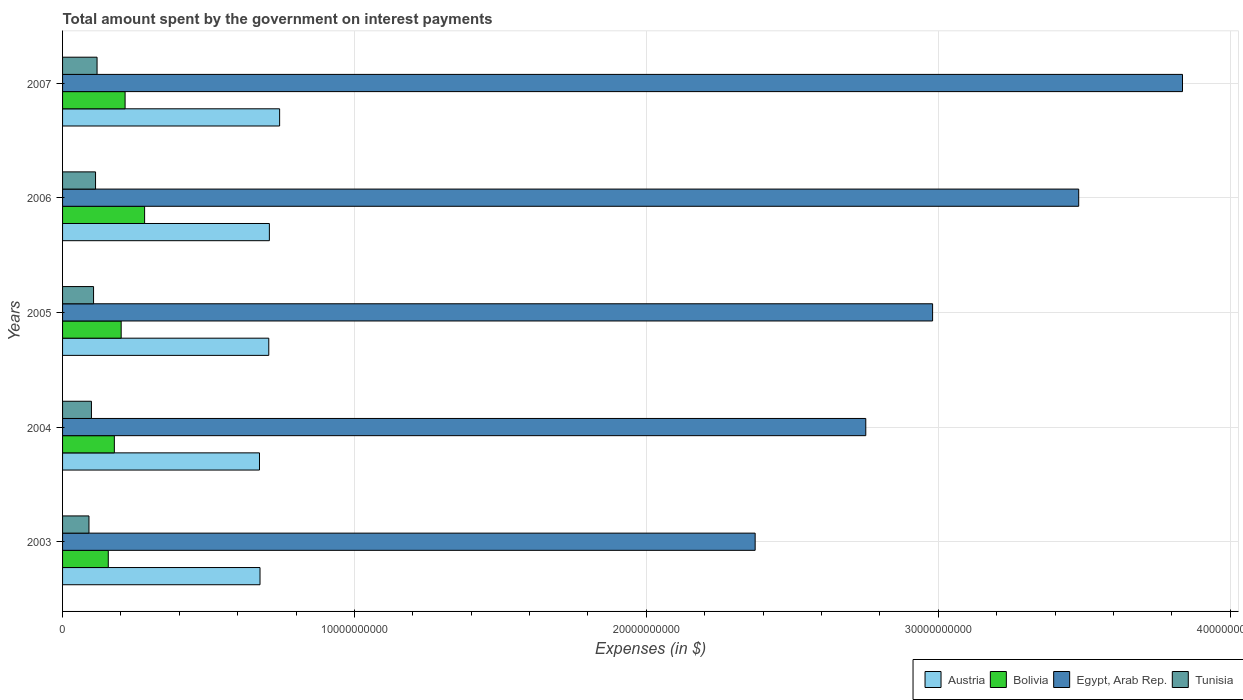Are the number of bars on each tick of the Y-axis equal?
Your answer should be compact. Yes. How many bars are there on the 1st tick from the top?
Keep it short and to the point. 4. What is the label of the 2nd group of bars from the top?
Your response must be concise. 2006. In how many cases, is the number of bars for a given year not equal to the number of legend labels?
Your answer should be compact. 0. What is the amount spent on interest payments by the government in Tunisia in 2006?
Ensure brevity in your answer.  1.13e+09. Across all years, what is the maximum amount spent on interest payments by the government in Bolivia?
Make the answer very short. 2.81e+09. Across all years, what is the minimum amount spent on interest payments by the government in Austria?
Give a very brief answer. 6.75e+09. In which year was the amount spent on interest payments by the government in Austria maximum?
Your answer should be compact. 2007. What is the total amount spent on interest payments by the government in Tunisia in the graph?
Your answer should be very brief. 5.27e+09. What is the difference between the amount spent on interest payments by the government in Bolivia in 2003 and that in 2005?
Keep it short and to the point. -4.42e+08. What is the difference between the amount spent on interest payments by the government in Bolivia in 2006 and the amount spent on interest payments by the government in Egypt, Arab Rep. in 2005?
Your response must be concise. -2.70e+1. What is the average amount spent on interest payments by the government in Bolivia per year?
Your answer should be compact. 2.06e+09. In the year 2007, what is the difference between the amount spent on interest payments by the government in Austria and amount spent on interest payments by the government in Egypt, Arab Rep.?
Provide a short and direct response. -3.09e+1. What is the ratio of the amount spent on interest payments by the government in Tunisia in 2003 to that in 2005?
Your answer should be compact. 0.85. Is the amount spent on interest payments by the government in Bolivia in 2003 less than that in 2006?
Offer a terse response. Yes. What is the difference between the highest and the second highest amount spent on interest payments by the government in Tunisia?
Ensure brevity in your answer.  5.21e+07. What is the difference between the highest and the lowest amount spent on interest payments by the government in Tunisia?
Keep it short and to the point. 2.78e+08. Is it the case that in every year, the sum of the amount spent on interest payments by the government in Bolivia and amount spent on interest payments by the government in Egypt, Arab Rep. is greater than the sum of amount spent on interest payments by the government in Tunisia and amount spent on interest payments by the government in Austria?
Provide a succinct answer. No. What does the 4th bar from the top in 2006 represents?
Your answer should be very brief. Austria. Are all the bars in the graph horizontal?
Your response must be concise. Yes. How many years are there in the graph?
Offer a terse response. 5. What is the difference between two consecutive major ticks on the X-axis?
Make the answer very short. 1.00e+1. Does the graph contain any zero values?
Offer a terse response. No. How are the legend labels stacked?
Your response must be concise. Horizontal. What is the title of the graph?
Keep it short and to the point. Total amount spent by the government on interest payments. What is the label or title of the X-axis?
Make the answer very short. Expenses (in $). What is the label or title of the Y-axis?
Make the answer very short. Years. What is the Expenses (in $) in Austria in 2003?
Your response must be concise. 6.76e+09. What is the Expenses (in $) in Bolivia in 2003?
Offer a terse response. 1.57e+09. What is the Expenses (in $) in Egypt, Arab Rep. in 2003?
Ensure brevity in your answer.  2.37e+1. What is the Expenses (in $) of Tunisia in 2003?
Offer a very short reply. 9.04e+08. What is the Expenses (in $) of Austria in 2004?
Ensure brevity in your answer.  6.75e+09. What is the Expenses (in $) in Bolivia in 2004?
Your response must be concise. 1.77e+09. What is the Expenses (in $) in Egypt, Arab Rep. in 2004?
Make the answer very short. 2.75e+1. What is the Expenses (in $) in Tunisia in 2004?
Offer a very short reply. 9.89e+08. What is the Expenses (in $) of Austria in 2005?
Provide a short and direct response. 7.06e+09. What is the Expenses (in $) of Bolivia in 2005?
Keep it short and to the point. 2.01e+09. What is the Expenses (in $) in Egypt, Arab Rep. in 2005?
Give a very brief answer. 2.98e+1. What is the Expenses (in $) of Tunisia in 2005?
Your response must be concise. 1.06e+09. What is the Expenses (in $) in Austria in 2006?
Your answer should be compact. 7.09e+09. What is the Expenses (in $) in Bolivia in 2006?
Your answer should be compact. 2.81e+09. What is the Expenses (in $) in Egypt, Arab Rep. in 2006?
Provide a succinct answer. 3.48e+1. What is the Expenses (in $) in Tunisia in 2006?
Provide a succinct answer. 1.13e+09. What is the Expenses (in $) in Austria in 2007?
Your response must be concise. 7.44e+09. What is the Expenses (in $) in Bolivia in 2007?
Offer a very short reply. 2.14e+09. What is the Expenses (in $) in Egypt, Arab Rep. in 2007?
Make the answer very short. 3.84e+1. What is the Expenses (in $) of Tunisia in 2007?
Provide a succinct answer. 1.18e+09. Across all years, what is the maximum Expenses (in $) of Austria?
Provide a short and direct response. 7.44e+09. Across all years, what is the maximum Expenses (in $) of Bolivia?
Make the answer very short. 2.81e+09. Across all years, what is the maximum Expenses (in $) in Egypt, Arab Rep.?
Offer a very short reply. 3.84e+1. Across all years, what is the maximum Expenses (in $) of Tunisia?
Offer a very short reply. 1.18e+09. Across all years, what is the minimum Expenses (in $) of Austria?
Provide a succinct answer. 6.75e+09. Across all years, what is the minimum Expenses (in $) of Bolivia?
Provide a succinct answer. 1.57e+09. Across all years, what is the minimum Expenses (in $) in Egypt, Arab Rep.?
Provide a short and direct response. 2.37e+1. Across all years, what is the minimum Expenses (in $) of Tunisia?
Offer a very short reply. 9.04e+08. What is the total Expenses (in $) in Austria in the graph?
Your response must be concise. 3.51e+1. What is the total Expenses (in $) of Bolivia in the graph?
Give a very brief answer. 1.03e+1. What is the total Expenses (in $) in Egypt, Arab Rep. in the graph?
Your answer should be compact. 1.54e+11. What is the total Expenses (in $) of Tunisia in the graph?
Your answer should be compact. 5.27e+09. What is the difference between the Expenses (in $) in Austria in 2003 and that in 2004?
Ensure brevity in your answer.  1.82e+07. What is the difference between the Expenses (in $) in Bolivia in 2003 and that in 2004?
Your response must be concise. -2.08e+08. What is the difference between the Expenses (in $) of Egypt, Arab Rep. in 2003 and that in 2004?
Offer a very short reply. -3.79e+09. What is the difference between the Expenses (in $) of Tunisia in 2003 and that in 2004?
Provide a short and direct response. -8.47e+07. What is the difference between the Expenses (in $) in Austria in 2003 and that in 2005?
Ensure brevity in your answer.  -3.00e+08. What is the difference between the Expenses (in $) of Bolivia in 2003 and that in 2005?
Your answer should be very brief. -4.42e+08. What is the difference between the Expenses (in $) of Egypt, Arab Rep. in 2003 and that in 2005?
Keep it short and to the point. -6.08e+09. What is the difference between the Expenses (in $) of Tunisia in 2003 and that in 2005?
Keep it short and to the point. -1.58e+08. What is the difference between the Expenses (in $) of Austria in 2003 and that in 2006?
Make the answer very short. -3.20e+08. What is the difference between the Expenses (in $) of Bolivia in 2003 and that in 2006?
Your answer should be compact. -1.24e+09. What is the difference between the Expenses (in $) in Egypt, Arab Rep. in 2003 and that in 2006?
Offer a terse response. -1.11e+1. What is the difference between the Expenses (in $) of Tunisia in 2003 and that in 2006?
Provide a short and direct response. -2.26e+08. What is the difference between the Expenses (in $) of Austria in 2003 and that in 2007?
Provide a succinct answer. -6.72e+08. What is the difference between the Expenses (in $) of Bolivia in 2003 and that in 2007?
Keep it short and to the point. -5.76e+08. What is the difference between the Expenses (in $) of Egypt, Arab Rep. in 2003 and that in 2007?
Provide a short and direct response. -1.46e+1. What is the difference between the Expenses (in $) of Tunisia in 2003 and that in 2007?
Your answer should be very brief. -2.78e+08. What is the difference between the Expenses (in $) in Austria in 2004 and that in 2005?
Offer a very short reply. -3.18e+08. What is the difference between the Expenses (in $) in Bolivia in 2004 and that in 2005?
Make the answer very short. -2.34e+08. What is the difference between the Expenses (in $) in Egypt, Arab Rep. in 2004 and that in 2005?
Your response must be concise. -2.29e+09. What is the difference between the Expenses (in $) in Tunisia in 2004 and that in 2005?
Make the answer very short. -7.31e+07. What is the difference between the Expenses (in $) of Austria in 2004 and that in 2006?
Offer a very short reply. -3.39e+08. What is the difference between the Expenses (in $) of Bolivia in 2004 and that in 2006?
Offer a terse response. -1.04e+09. What is the difference between the Expenses (in $) in Egypt, Arab Rep. in 2004 and that in 2006?
Offer a very short reply. -7.29e+09. What is the difference between the Expenses (in $) of Tunisia in 2004 and that in 2006?
Your answer should be very brief. -1.41e+08. What is the difference between the Expenses (in $) in Austria in 2004 and that in 2007?
Provide a short and direct response. -6.90e+08. What is the difference between the Expenses (in $) in Bolivia in 2004 and that in 2007?
Your answer should be compact. -3.68e+08. What is the difference between the Expenses (in $) of Egypt, Arab Rep. in 2004 and that in 2007?
Provide a succinct answer. -1.09e+1. What is the difference between the Expenses (in $) in Tunisia in 2004 and that in 2007?
Your answer should be very brief. -1.93e+08. What is the difference between the Expenses (in $) in Austria in 2005 and that in 2006?
Ensure brevity in your answer.  -2.02e+07. What is the difference between the Expenses (in $) in Bolivia in 2005 and that in 2006?
Give a very brief answer. -8.03e+08. What is the difference between the Expenses (in $) of Egypt, Arab Rep. in 2005 and that in 2006?
Your answer should be compact. -5.01e+09. What is the difference between the Expenses (in $) of Tunisia in 2005 and that in 2006?
Offer a very short reply. -6.77e+07. What is the difference between the Expenses (in $) in Austria in 2005 and that in 2007?
Offer a terse response. -3.71e+08. What is the difference between the Expenses (in $) of Bolivia in 2005 and that in 2007?
Give a very brief answer. -1.34e+08. What is the difference between the Expenses (in $) of Egypt, Arab Rep. in 2005 and that in 2007?
Ensure brevity in your answer.  -8.56e+09. What is the difference between the Expenses (in $) in Tunisia in 2005 and that in 2007?
Keep it short and to the point. -1.20e+08. What is the difference between the Expenses (in $) of Austria in 2006 and that in 2007?
Offer a terse response. -3.51e+08. What is the difference between the Expenses (in $) in Bolivia in 2006 and that in 2007?
Provide a succinct answer. 6.69e+08. What is the difference between the Expenses (in $) of Egypt, Arab Rep. in 2006 and that in 2007?
Keep it short and to the point. -3.56e+09. What is the difference between the Expenses (in $) of Tunisia in 2006 and that in 2007?
Offer a terse response. -5.21e+07. What is the difference between the Expenses (in $) of Austria in 2003 and the Expenses (in $) of Bolivia in 2004?
Provide a succinct answer. 4.99e+09. What is the difference between the Expenses (in $) in Austria in 2003 and the Expenses (in $) in Egypt, Arab Rep. in 2004?
Your answer should be very brief. -2.08e+1. What is the difference between the Expenses (in $) of Austria in 2003 and the Expenses (in $) of Tunisia in 2004?
Give a very brief answer. 5.78e+09. What is the difference between the Expenses (in $) of Bolivia in 2003 and the Expenses (in $) of Egypt, Arab Rep. in 2004?
Provide a succinct answer. -2.60e+1. What is the difference between the Expenses (in $) in Bolivia in 2003 and the Expenses (in $) in Tunisia in 2004?
Your answer should be compact. 5.77e+08. What is the difference between the Expenses (in $) in Egypt, Arab Rep. in 2003 and the Expenses (in $) in Tunisia in 2004?
Give a very brief answer. 2.27e+1. What is the difference between the Expenses (in $) of Austria in 2003 and the Expenses (in $) of Bolivia in 2005?
Make the answer very short. 4.76e+09. What is the difference between the Expenses (in $) in Austria in 2003 and the Expenses (in $) in Egypt, Arab Rep. in 2005?
Keep it short and to the point. -2.30e+1. What is the difference between the Expenses (in $) of Austria in 2003 and the Expenses (in $) of Tunisia in 2005?
Keep it short and to the point. 5.70e+09. What is the difference between the Expenses (in $) of Bolivia in 2003 and the Expenses (in $) of Egypt, Arab Rep. in 2005?
Provide a short and direct response. -2.82e+1. What is the difference between the Expenses (in $) of Bolivia in 2003 and the Expenses (in $) of Tunisia in 2005?
Your response must be concise. 5.04e+08. What is the difference between the Expenses (in $) in Egypt, Arab Rep. in 2003 and the Expenses (in $) in Tunisia in 2005?
Offer a very short reply. 2.27e+1. What is the difference between the Expenses (in $) of Austria in 2003 and the Expenses (in $) of Bolivia in 2006?
Provide a succinct answer. 3.95e+09. What is the difference between the Expenses (in $) of Austria in 2003 and the Expenses (in $) of Egypt, Arab Rep. in 2006?
Keep it short and to the point. -2.80e+1. What is the difference between the Expenses (in $) in Austria in 2003 and the Expenses (in $) in Tunisia in 2006?
Your answer should be very brief. 5.63e+09. What is the difference between the Expenses (in $) in Bolivia in 2003 and the Expenses (in $) in Egypt, Arab Rep. in 2006?
Provide a succinct answer. -3.32e+1. What is the difference between the Expenses (in $) in Bolivia in 2003 and the Expenses (in $) in Tunisia in 2006?
Keep it short and to the point. 4.36e+08. What is the difference between the Expenses (in $) of Egypt, Arab Rep. in 2003 and the Expenses (in $) of Tunisia in 2006?
Offer a terse response. 2.26e+1. What is the difference between the Expenses (in $) of Austria in 2003 and the Expenses (in $) of Bolivia in 2007?
Ensure brevity in your answer.  4.62e+09. What is the difference between the Expenses (in $) of Austria in 2003 and the Expenses (in $) of Egypt, Arab Rep. in 2007?
Your response must be concise. -3.16e+1. What is the difference between the Expenses (in $) in Austria in 2003 and the Expenses (in $) in Tunisia in 2007?
Ensure brevity in your answer.  5.58e+09. What is the difference between the Expenses (in $) of Bolivia in 2003 and the Expenses (in $) of Egypt, Arab Rep. in 2007?
Keep it short and to the point. -3.68e+1. What is the difference between the Expenses (in $) in Bolivia in 2003 and the Expenses (in $) in Tunisia in 2007?
Provide a succinct answer. 3.84e+08. What is the difference between the Expenses (in $) of Egypt, Arab Rep. in 2003 and the Expenses (in $) of Tunisia in 2007?
Offer a very short reply. 2.25e+1. What is the difference between the Expenses (in $) in Austria in 2004 and the Expenses (in $) in Bolivia in 2005?
Make the answer very short. 4.74e+09. What is the difference between the Expenses (in $) of Austria in 2004 and the Expenses (in $) of Egypt, Arab Rep. in 2005?
Your answer should be very brief. -2.31e+1. What is the difference between the Expenses (in $) in Austria in 2004 and the Expenses (in $) in Tunisia in 2005?
Offer a terse response. 5.68e+09. What is the difference between the Expenses (in $) of Bolivia in 2004 and the Expenses (in $) of Egypt, Arab Rep. in 2005?
Make the answer very short. -2.80e+1. What is the difference between the Expenses (in $) in Bolivia in 2004 and the Expenses (in $) in Tunisia in 2005?
Offer a very short reply. 7.12e+08. What is the difference between the Expenses (in $) in Egypt, Arab Rep. in 2004 and the Expenses (in $) in Tunisia in 2005?
Ensure brevity in your answer.  2.65e+1. What is the difference between the Expenses (in $) of Austria in 2004 and the Expenses (in $) of Bolivia in 2006?
Ensure brevity in your answer.  3.94e+09. What is the difference between the Expenses (in $) in Austria in 2004 and the Expenses (in $) in Egypt, Arab Rep. in 2006?
Your answer should be compact. -2.81e+1. What is the difference between the Expenses (in $) in Austria in 2004 and the Expenses (in $) in Tunisia in 2006?
Ensure brevity in your answer.  5.62e+09. What is the difference between the Expenses (in $) of Bolivia in 2004 and the Expenses (in $) of Egypt, Arab Rep. in 2006?
Keep it short and to the point. -3.30e+1. What is the difference between the Expenses (in $) in Bolivia in 2004 and the Expenses (in $) in Tunisia in 2006?
Offer a very short reply. 6.44e+08. What is the difference between the Expenses (in $) of Egypt, Arab Rep. in 2004 and the Expenses (in $) of Tunisia in 2006?
Provide a short and direct response. 2.64e+1. What is the difference between the Expenses (in $) of Austria in 2004 and the Expenses (in $) of Bolivia in 2007?
Give a very brief answer. 4.60e+09. What is the difference between the Expenses (in $) in Austria in 2004 and the Expenses (in $) in Egypt, Arab Rep. in 2007?
Give a very brief answer. -3.16e+1. What is the difference between the Expenses (in $) of Austria in 2004 and the Expenses (in $) of Tunisia in 2007?
Your answer should be compact. 5.56e+09. What is the difference between the Expenses (in $) of Bolivia in 2004 and the Expenses (in $) of Egypt, Arab Rep. in 2007?
Give a very brief answer. -3.66e+1. What is the difference between the Expenses (in $) of Bolivia in 2004 and the Expenses (in $) of Tunisia in 2007?
Give a very brief answer. 5.92e+08. What is the difference between the Expenses (in $) of Egypt, Arab Rep. in 2004 and the Expenses (in $) of Tunisia in 2007?
Keep it short and to the point. 2.63e+1. What is the difference between the Expenses (in $) of Austria in 2005 and the Expenses (in $) of Bolivia in 2006?
Provide a succinct answer. 4.25e+09. What is the difference between the Expenses (in $) of Austria in 2005 and the Expenses (in $) of Egypt, Arab Rep. in 2006?
Make the answer very short. -2.77e+1. What is the difference between the Expenses (in $) in Austria in 2005 and the Expenses (in $) in Tunisia in 2006?
Offer a very short reply. 5.94e+09. What is the difference between the Expenses (in $) of Bolivia in 2005 and the Expenses (in $) of Egypt, Arab Rep. in 2006?
Make the answer very short. -3.28e+1. What is the difference between the Expenses (in $) in Bolivia in 2005 and the Expenses (in $) in Tunisia in 2006?
Keep it short and to the point. 8.78e+08. What is the difference between the Expenses (in $) of Egypt, Arab Rep. in 2005 and the Expenses (in $) of Tunisia in 2006?
Provide a succinct answer. 2.87e+1. What is the difference between the Expenses (in $) of Austria in 2005 and the Expenses (in $) of Bolivia in 2007?
Keep it short and to the point. 4.92e+09. What is the difference between the Expenses (in $) of Austria in 2005 and the Expenses (in $) of Egypt, Arab Rep. in 2007?
Keep it short and to the point. -3.13e+1. What is the difference between the Expenses (in $) in Austria in 2005 and the Expenses (in $) in Tunisia in 2007?
Provide a short and direct response. 5.88e+09. What is the difference between the Expenses (in $) of Bolivia in 2005 and the Expenses (in $) of Egypt, Arab Rep. in 2007?
Your answer should be very brief. -3.64e+1. What is the difference between the Expenses (in $) of Bolivia in 2005 and the Expenses (in $) of Tunisia in 2007?
Offer a terse response. 8.26e+08. What is the difference between the Expenses (in $) of Egypt, Arab Rep. in 2005 and the Expenses (in $) of Tunisia in 2007?
Your answer should be compact. 2.86e+1. What is the difference between the Expenses (in $) in Austria in 2006 and the Expenses (in $) in Bolivia in 2007?
Your answer should be very brief. 4.94e+09. What is the difference between the Expenses (in $) of Austria in 2006 and the Expenses (in $) of Egypt, Arab Rep. in 2007?
Offer a terse response. -3.13e+1. What is the difference between the Expenses (in $) in Austria in 2006 and the Expenses (in $) in Tunisia in 2007?
Give a very brief answer. 5.90e+09. What is the difference between the Expenses (in $) of Bolivia in 2006 and the Expenses (in $) of Egypt, Arab Rep. in 2007?
Ensure brevity in your answer.  -3.56e+1. What is the difference between the Expenses (in $) in Bolivia in 2006 and the Expenses (in $) in Tunisia in 2007?
Your response must be concise. 1.63e+09. What is the difference between the Expenses (in $) of Egypt, Arab Rep. in 2006 and the Expenses (in $) of Tunisia in 2007?
Make the answer very short. 3.36e+1. What is the average Expenses (in $) of Austria per year?
Keep it short and to the point. 7.02e+09. What is the average Expenses (in $) in Bolivia per year?
Make the answer very short. 2.06e+09. What is the average Expenses (in $) in Egypt, Arab Rep. per year?
Your answer should be very brief. 3.08e+1. What is the average Expenses (in $) of Tunisia per year?
Ensure brevity in your answer.  1.05e+09. In the year 2003, what is the difference between the Expenses (in $) of Austria and Expenses (in $) of Bolivia?
Your answer should be compact. 5.20e+09. In the year 2003, what is the difference between the Expenses (in $) of Austria and Expenses (in $) of Egypt, Arab Rep.?
Provide a succinct answer. -1.70e+1. In the year 2003, what is the difference between the Expenses (in $) in Austria and Expenses (in $) in Tunisia?
Your answer should be very brief. 5.86e+09. In the year 2003, what is the difference between the Expenses (in $) in Bolivia and Expenses (in $) in Egypt, Arab Rep.?
Make the answer very short. -2.22e+1. In the year 2003, what is the difference between the Expenses (in $) in Bolivia and Expenses (in $) in Tunisia?
Provide a succinct answer. 6.62e+08. In the year 2003, what is the difference between the Expenses (in $) of Egypt, Arab Rep. and Expenses (in $) of Tunisia?
Offer a terse response. 2.28e+1. In the year 2004, what is the difference between the Expenses (in $) in Austria and Expenses (in $) in Bolivia?
Provide a succinct answer. 4.97e+09. In the year 2004, what is the difference between the Expenses (in $) of Austria and Expenses (in $) of Egypt, Arab Rep.?
Provide a succinct answer. -2.08e+1. In the year 2004, what is the difference between the Expenses (in $) in Austria and Expenses (in $) in Tunisia?
Provide a succinct answer. 5.76e+09. In the year 2004, what is the difference between the Expenses (in $) in Bolivia and Expenses (in $) in Egypt, Arab Rep.?
Make the answer very short. -2.57e+1. In the year 2004, what is the difference between the Expenses (in $) in Bolivia and Expenses (in $) in Tunisia?
Provide a short and direct response. 7.85e+08. In the year 2004, what is the difference between the Expenses (in $) in Egypt, Arab Rep. and Expenses (in $) in Tunisia?
Offer a terse response. 2.65e+1. In the year 2005, what is the difference between the Expenses (in $) of Austria and Expenses (in $) of Bolivia?
Your answer should be compact. 5.06e+09. In the year 2005, what is the difference between the Expenses (in $) in Austria and Expenses (in $) in Egypt, Arab Rep.?
Keep it short and to the point. -2.27e+1. In the year 2005, what is the difference between the Expenses (in $) in Austria and Expenses (in $) in Tunisia?
Ensure brevity in your answer.  6.00e+09. In the year 2005, what is the difference between the Expenses (in $) in Bolivia and Expenses (in $) in Egypt, Arab Rep.?
Ensure brevity in your answer.  -2.78e+1. In the year 2005, what is the difference between the Expenses (in $) in Bolivia and Expenses (in $) in Tunisia?
Ensure brevity in your answer.  9.46e+08. In the year 2005, what is the difference between the Expenses (in $) in Egypt, Arab Rep. and Expenses (in $) in Tunisia?
Your response must be concise. 2.87e+1. In the year 2006, what is the difference between the Expenses (in $) in Austria and Expenses (in $) in Bolivia?
Make the answer very short. 4.27e+09. In the year 2006, what is the difference between the Expenses (in $) of Austria and Expenses (in $) of Egypt, Arab Rep.?
Provide a short and direct response. -2.77e+1. In the year 2006, what is the difference between the Expenses (in $) in Austria and Expenses (in $) in Tunisia?
Ensure brevity in your answer.  5.96e+09. In the year 2006, what is the difference between the Expenses (in $) of Bolivia and Expenses (in $) of Egypt, Arab Rep.?
Make the answer very short. -3.20e+1. In the year 2006, what is the difference between the Expenses (in $) of Bolivia and Expenses (in $) of Tunisia?
Ensure brevity in your answer.  1.68e+09. In the year 2006, what is the difference between the Expenses (in $) in Egypt, Arab Rep. and Expenses (in $) in Tunisia?
Offer a terse response. 3.37e+1. In the year 2007, what is the difference between the Expenses (in $) in Austria and Expenses (in $) in Bolivia?
Keep it short and to the point. 5.29e+09. In the year 2007, what is the difference between the Expenses (in $) of Austria and Expenses (in $) of Egypt, Arab Rep.?
Your answer should be compact. -3.09e+1. In the year 2007, what is the difference between the Expenses (in $) in Austria and Expenses (in $) in Tunisia?
Ensure brevity in your answer.  6.25e+09. In the year 2007, what is the difference between the Expenses (in $) of Bolivia and Expenses (in $) of Egypt, Arab Rep.?
Your answer should be compact. -3.62e+1. In the year 2007, what is the difference between the Expenses (in $) of Bolivia and Expenses (in $) of Tunisia?
Provide a short and direct response. 9.60e+08. In the year 2007, what is the difference between the Expenses (in $) of Egypt, Arab Rep. and Expenses (in $) of Tunisia?
Make the answer very short. 3.72e+1. What is the ratio of the Expenses (in $) in Bolivia in 2003 to that in 2004?
Your answer should be compact. 0.88. What is the ratio of the Expenses (in $) in Egypt, Arab Rep. in 2003 to that in 2004?
Provide a short and direct response. 0.86. What is the ratio of the Expenses (in $) in Tunisia in 2003 to that in 2004?
Give a very brief answer. 0.91. What is the ratio of the Expenses (in $) of Austria in 2003 to that in 2005?
Your answer should be very brief. 0.96. What is the ratio of the Expenses (in $) of Bolivia in 2003 to that in 2005?
Your answer should be compact. 0.78. What is the ratio of the Expenses (in $) in Egypt, Arab Rep. in 2003 to that in 2005?
Your answer should be compact. 0.8. What is the ratio of the Expenses (in $) in Tunisia in 2003 to that in 2005?
Your answer should be very brief. 0.85. What is the ratio of the Expenses (in $) of Austria in 2003 to that in 2006?
Provide a succinct answer. 0.95. What is the ratio of the Expenses (in $) in Bolivia in 2003 to that in 2006?
Your response must be concise. 0.56. What is the ratio of the Expenses (in $) of Egypt, Arab Rep. in 2003 to that in 2006?
Offer a very short reply. 0.68. What is the ratio of the Expenses (in $) in Tunisia in 2003 to that in 2006?
Offer a very short reply. 0.8. What is the ratio of the Expenses (in $) of Austria in 2003 to that in 2007?
Give a very brief answer. 0.91. What is the ratio of the Expenses (in $) in Bolivia in 2003 to that in 2007?
Your answer should be compact. 0.73. What is the ratio of the Expenses (in $) in Egypt, Arab Rep. in 2003 to that in 2007?
Ensure brevity in your answer.  0.62. What is the ratio of the Expenses (in $) of Tunisia in 2003 to that in 2007?
Your response must be concise. 0.77. What is the ratio of the Expenses (in $) of Austria in 2004 to that in 2005?
Give a very brief answer. 0.95. What is the ratio of the Expenses (in $) in Bolivia in 2004 to that in 2005?
Your answer should be compact. 0.88. What is the ratio of the Expenses (in $) of Egypt, Arab Rep. in 2004 to that in 2005?
Offer a terse response. 0.92. What is the ratio of the Expenses (in $) in Tunisia in 2004 to that in 2005?
Your answer should be very brief. 0.93. What is the ratio of the Expenses (in $) in Austria in 2004 to that in 2006?
Your answer should be very brief. 0.95. What is the ratio of the Expenses (in $) of Bolivia in 2004 to that in 2006?
Offer a very short reply. 0.63. What is the ratio of the Expenses (in $) of Egypt, Arab Rep. in 2004 to that in 2006?
Keep it short and to the point. 0.79. What is the ratio of the Expenses (in $) in Tunisia in 2004 to that in 2006?
Your answer should be compact. 0.88. What is the ratio of the Expenses (in $) of Austria in 2004 to that in 2007?
Keep it short and to the point. 0.91. What is the ratio of the Expenses (in $) of Bolivia in 2004 to that in 2007?
Make the answer very short. 0.83. What is the ratio of the Expenses (in $) of Egypt, Arab Rep. in 2004 to that in 2007?
Your response must be concise. 0.72. What is the ratio of the Expenses (in $) of Tunisia in 2004 to that in 2007?
Offer a terse response. 0.84. What is the ratio of the Expenses (in $) in Austria in 2005 to that in 2006?
Give a very brief answer. 1. What is the ratio of the Expenses (in $) of Egypt, Arab Rep. in 2005 to that in 2006?
Offer a terse response. 0.86. What is the ratio of the Expenses (in $) in Tunisia in 2005 to that in 2006?
Provide a short and direct response. 0.94. What is the ratio of the Expenses (in $) in Austria in 2005 to that in 2007?
Give a very brief answer. 0.95. What is the ratio of the Expenses (in $) in Bolivia in 2005 to that in 2007?
Provide a short and direct response. 0.94. What is the ratio of the Expenses (in $) in Egypt, Arab Rep. in 2005 to that in 2007?
Provide a short and direct response. 0.78. What is the ratio of the Expenses (in $) of Tunisia in 2005 to that in 2007?
Ensure brevity in your answer.  0.9. What is the ratio of the Expenses (in $) in Austria in 2006 to that in 2007?
Offer a terse response. 0.95. What is the ratio of the Expenses (in $) of Bolivia in 2006 to that in 2007?
Offer a terse response. 1.31. What is the ratio of the Expenses (in $) in Egypt, Arab Rep. in 2006 to that in 2007?
Your answer should be compact. 0.91. What is the ratio of the Expenses (in $) in Tunisia in 2006 to that in 2007?
Ensure brevity in your answer.  0.96. What is the difference between the highest and the second highest Expenses (in $) in Austria?
Provide a short and direct response. 3.51e+08. What is the difference between the highest and the second highest Expenses (in $) in Bolivia?
Offer a terse response. 6.69e+08. What is the difference between the highest and the second highest Expenses (in $) of Egypt, Arab Rep.?
Your answer should be compact. 3.56e+09. What is the difference between the highest and the second highest Expenses (in $) in Tunisia?
Your response must be concise. 5.21e+07. What is the difference between the highest and the lowest Expenses (in $) in Austria?
Keep it short and to the point. 6.90e+08. What is the difference between the highest and the lowest Expenses (in $) of Bolivia?
Provide a succinct answer. 1.24e+09. What is the difference between the highest and the lowest Expenses (in $) of Egypt, Arab Rep.?
Make the answer very short. 1.46e+1. What is the difference between the highest and the lowest Expenses (in $) of Tunisia?
Offer a very short reply. 2.78e+08. 